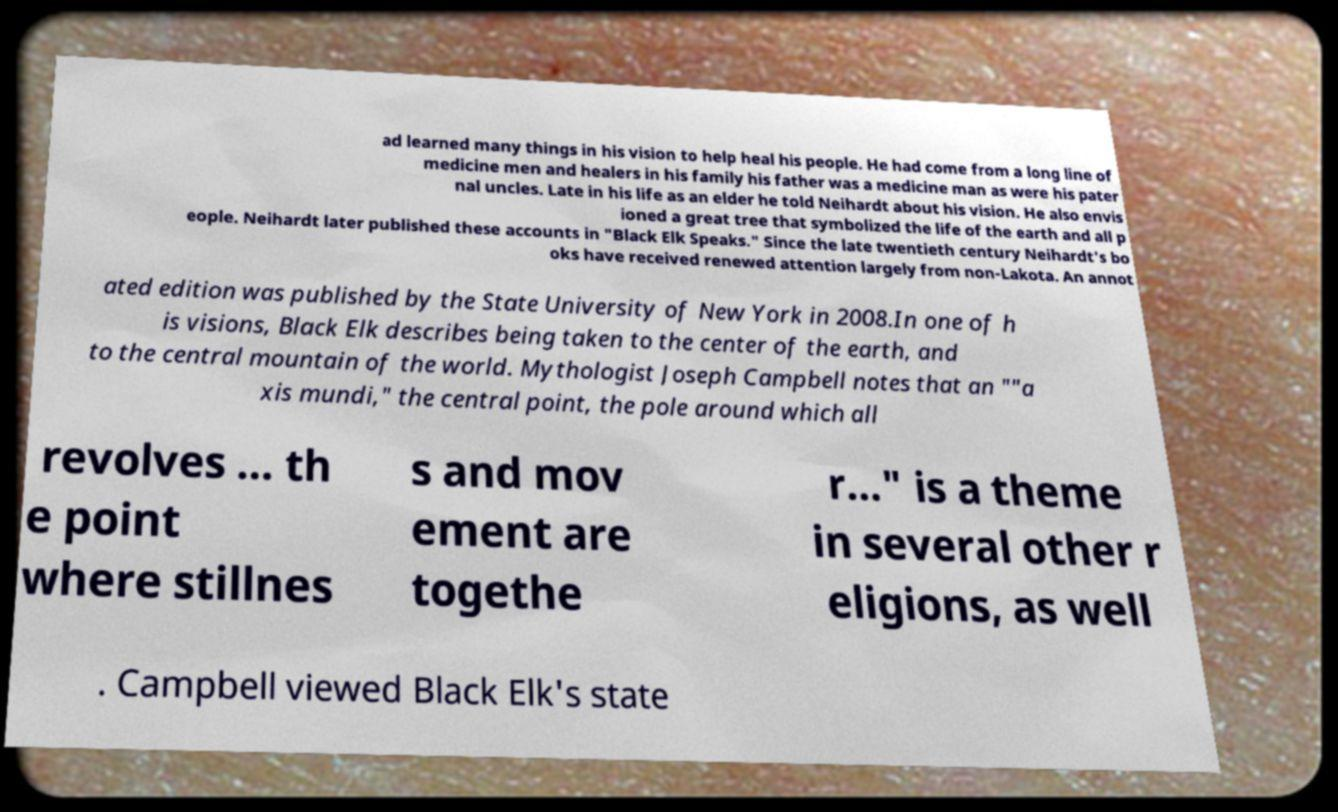Can you read and provide the text displayed in the image?This photo seems to have some interesting text. Can you extract and type it out for me? ad learned many things in his vision to help heal his people. He had come from a long line of medicine men and healers in his family his father was a medicine man as were his pater nal uncles. Late in his life as an elder he told Neihardt about his vision. He also envis ioned a great tree that symbolized the life of the earth and all p eople. Neihardt later published these accounts in "Black Elk Speaks." Since the late twentieth century Neihardt's bo oks have received renewed attention largely from non-Lakota. An annot ated edition was published by the State University of New York in 2008.In one of h is visions, Black Elk describes being taken to the center of the earth, and to the central mountain of the world. Mythologist Joseph Campbell notes that an ""a xis mundi," the central point, the pole around which all revolves ... th e point where stillnes s and mov ement are togethe r..." is a theme in several other r eligions, as well . Campbell viewed Black Elk's state 